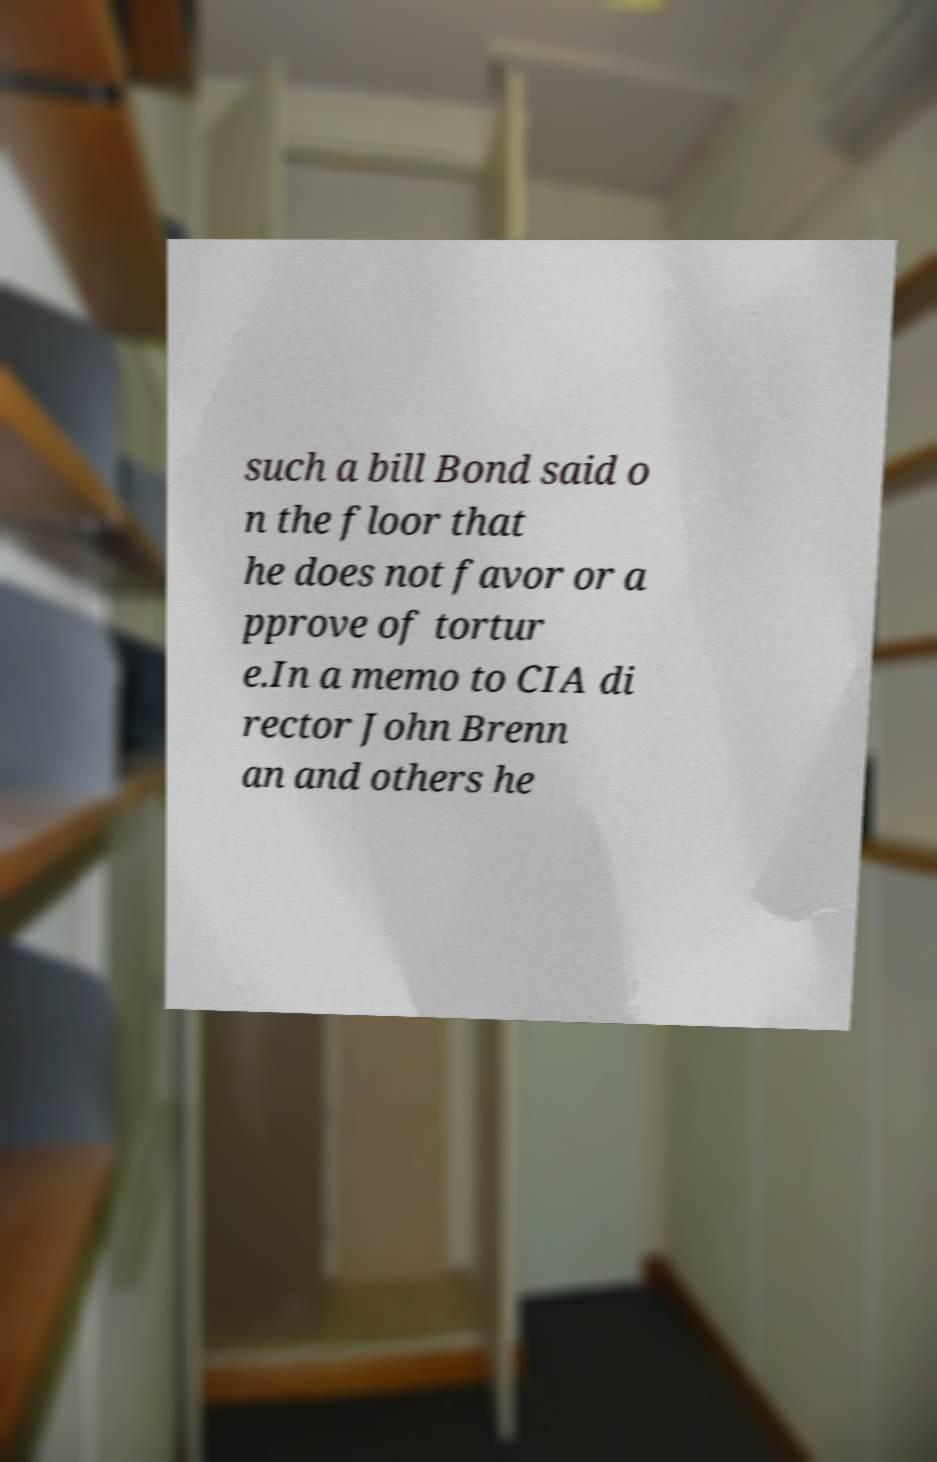What messages or text are displayed in this image? I need them in a readable, typed format. such a bill Bond said o n the floor that he does not favor or a pprove of tortur e.In a memo to CIA di rector John Brenn an and others he 